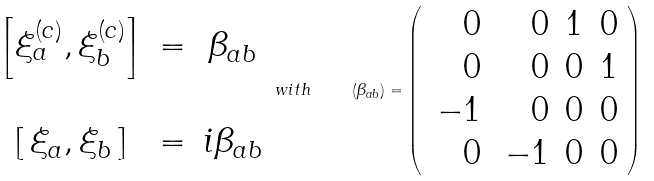Convert formula to latex. <formula><loc_0><loc_0><loc_500><loc_500>\begin{array} { c c c } \left [ \xi ^ { ( c ) } _ { a } , \xi ^ { ( c ) } _ { b } \right ] & = & \beta _ { a b } \\ & & \\ \left [ \, \xi _ { a } , \xi _ { b } \, \right ] & = & i \beta _ { a b } \end{array} \, w i t h \quad \, \left ( \beta _ { a b } \right ) = \left ( \begin{array} { r r c c } \, 0 & \, 0 & 1 & 0 \\ \, 0 & \, 0 & 0 & 1 \\ \, - 1 & \, 0 & 0 & 0 \\ \, 0 & \, - 1 & 0 & 0 \end{array} \right )</formula> 